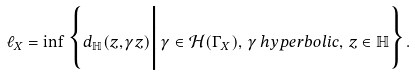Convert formula to latex. <formula><loc_0><loc_0><loc_500><loc_500>\ell _ { X } = \inf \Big \{ { d _ { \mathbb { H } } ( z , \gamma z ) \Big | \, \gamma \in \mathcal { H } ( \Gamma _ { X } ) , \, \gamma \, h y p e r b o l i c , \, z \in \mathbb { H } \Big \} } .</formula> 